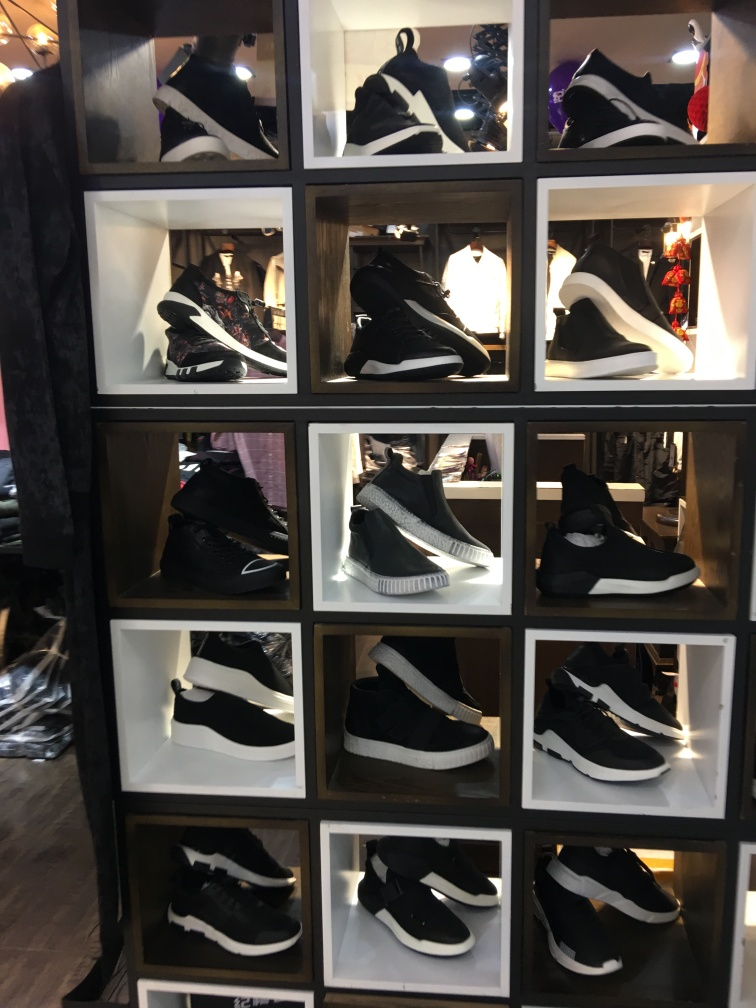Can you tell me about the lighting conditions in this store? The store appears to be illuminated by strong overhead lighting, which is casting a glow on the sneakers while also causing some reflections and glare on the glass. This direct lighting helps highlight the shoes but may create some visibility issues for the viewer. 